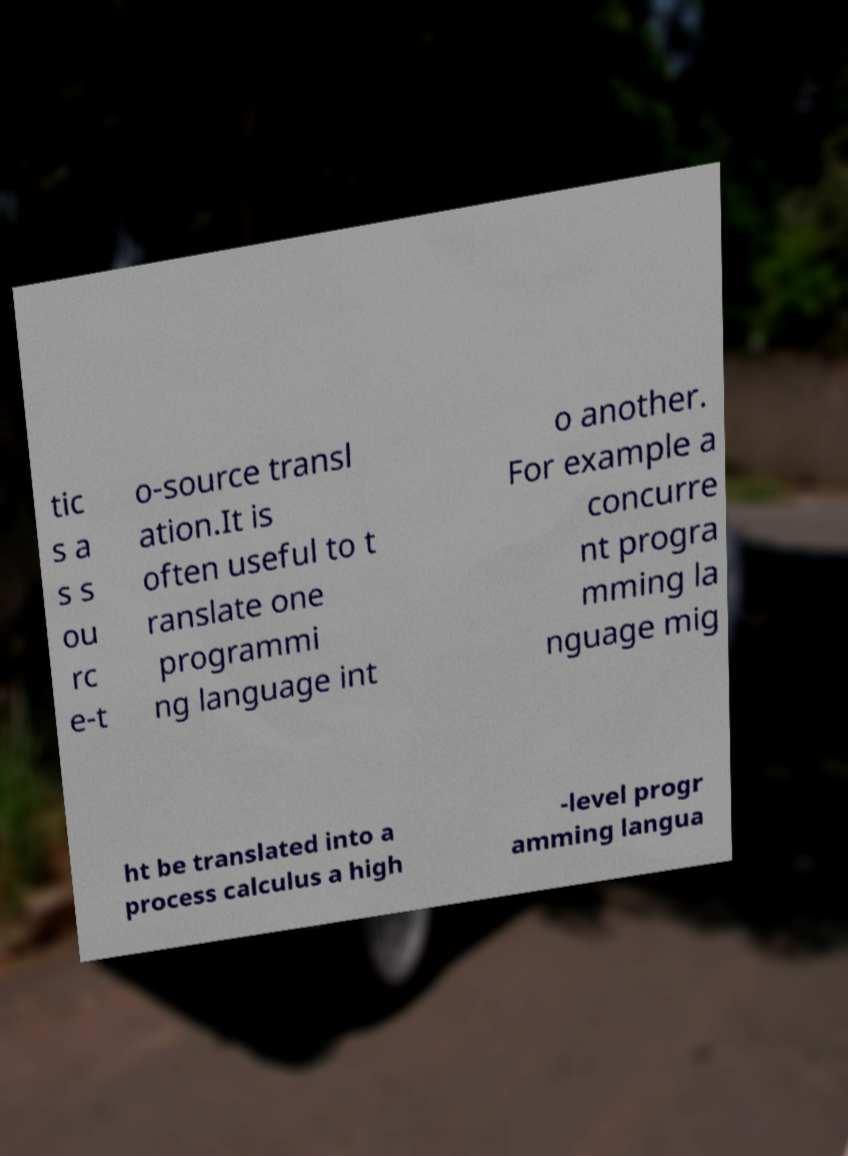Please identify and transcribe the text found in this image. tic s a s s ou rc e-t o-source transl ation.It is often useful to t ranslate one programmi ng language int o another. For example a concurre nt progra mming la nguage mig ht be translated into a process calculus a high -level progr amming langua 